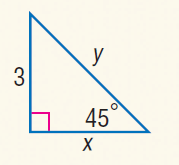Question: Find x.
Choices:
A. 3
B. 4
C. 5
D. 3 \sqrt { 3 }
Answer with the letter. Answer: A Question: Find y.
Choices:
A. \sqrt { 2 }
B. 2
C. 4
D. 3 \sqrt { 2 }
Answer with the letter. Answer: D 